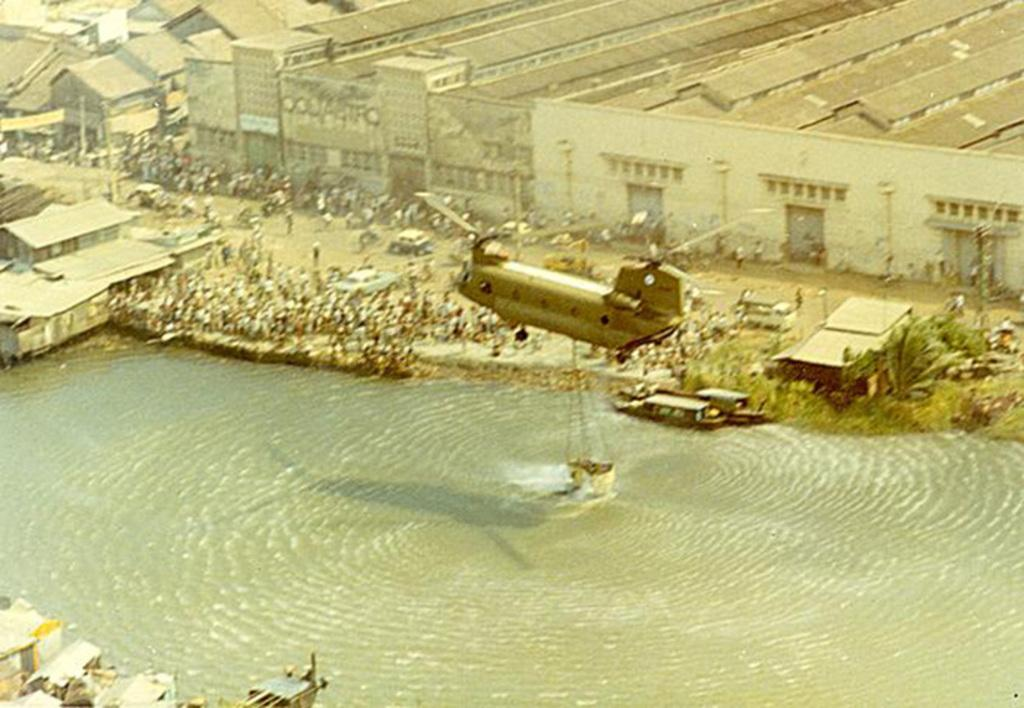How many people are in the image? There are people in the image, but the exact number is not specified. What is the primary element visible in the image? Water is visible in the image. What type of vehicle is present in the image? There is an aircraft in the image. What is attached to the aircraft? There is an object attached to the aircraft, but its specific nature is not mentioned. What type of structures can be seen in the image? There are buildings in the image. What type of vegetation is present in the image? There are trees in the image. What type of man-made objects can be seen in the image? There are poles in the image. How many cats are sitting on the poles in the image? There are no cats present in the image. What is the position of the rain in the image? There is no mention of rain in the image. 